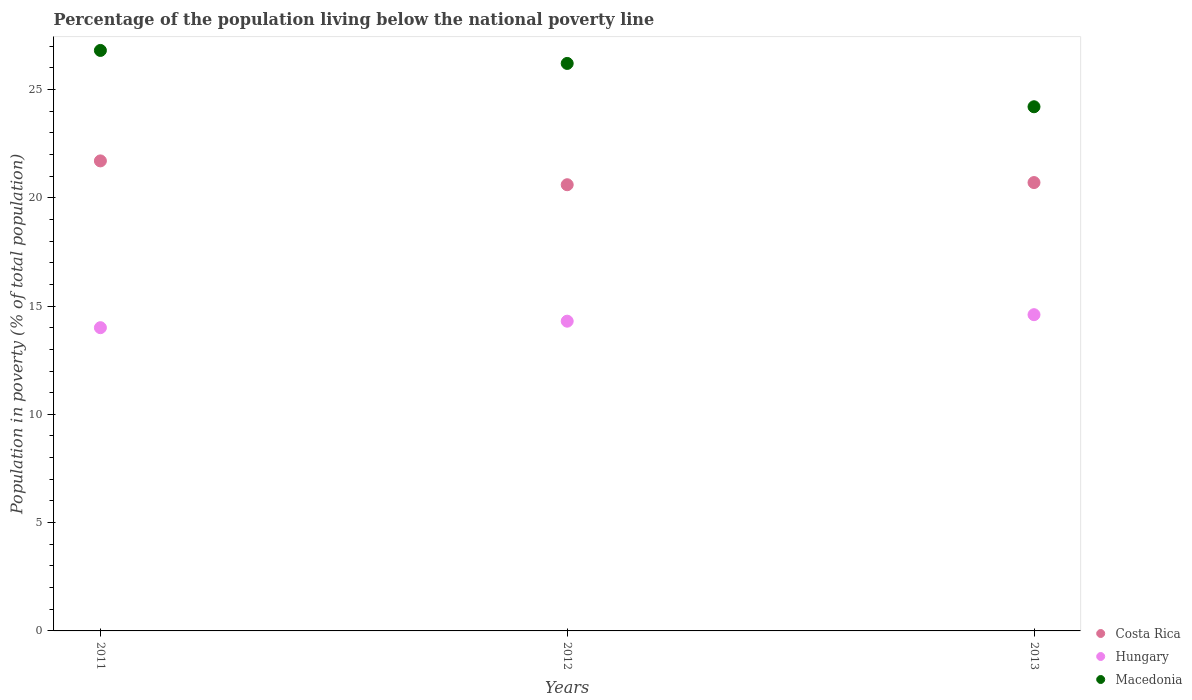How many different coloured dotlines are there?
Provide a succinct answer. 3. Is the number of dotlines equal to the number of legend labels?
Ensure brevity in your answer.  Yes. What is the percentage of the population living below the national poverty line in Costa Rica in 2013?
Your answer should be very brief. 20.7. Across all years, what is the maximum percentage of the population living below the national poverty line in Macedonia?
Your answer should be very brief. 26.8. Across all years, what is the minimum percentage of the population living below the national poverty line in Macedonia?
Make the answer very short. 24.2. In which year was the percentage of the population living below the national poverty line in Costa Rica maximum?
Provide a short and direct response. 2011. What is the total percentage of the population living below the national poverty line in Macedonia in the graph?
Your response must be concise. 77.2. What is the difference between the percentage of the population living below the national poverty line in Hungary in 2012 and that in 2013?
Your response must be concise. -0.3. What is the difference between the percentage of the population living below the national poverty line in Hungary in 2011 and the percentage of the population living below the national poverty line in Macedonia in 2013?
Ensure brevity in your answer.  -10.2. What is the average percentage of the population living below the national poverty line in Hungary per year?
Provide a succinct answer. 14.3. In the year 2011, what is the difference between the percentage of the population living below the national poverty line in Macedonia and percentage of the population living below the national poverty line in Costa Rica?
Offer a very short reply. 5.1. In how many years, is the percentage of the population living below the national poverty line in Costa Rica greater than 1 %?
Make the answer very short. 3. What is the ratio of the percentage of the population living below the national poverty line in Costa Rica in 2011 to that in 2013?
Offer a terse response. 1.05. Is the difference between the percentage of the population living below the national poverty line in Macedonia in 2011 and 2012 greater than the difference between the percentage of the population living below the national poverty line in Costa Rica in 2011 and 2012?
Offer a very short reply. No. What is the difference between the highest and the second highest percentage of the population living below the national poverty line in Macedonia?
Ensure brevity in your answer.  0.6. What is the difference between the highest and the lowest percentage of the population living below the national poverty line in Macedonia?
Keep it short and to the point. 2.6. In how many years, is the percentage of the population living below the national poverty line in Costa Rica greater than the average percentage of the population living below the national poverty line in Costa Rica taken over all years?
Offer a very short reply. 1. Is the sum of the percentage of the population living below the national poverty line in Macedonia in 2011 and 2013 greater than the maximum percentage of the population living below the national poverty line in Costa Rica across all years?
Provide a succinct answer. Yes. Is it the case that in every year, the sum of the percentage of the population living below the national poverty line in Costa Rica and percentage of the population living below the national poverty line in Macedonia  is greater than the percentage of the population living below the national poverty line in Hungary?
Your answer should be compact. Yes. Does the percentage of the population living below the national poverty line in Macedonia monotonically increase over the years?
Offer a terse response. No. Is the percentage of the population living below the national poverty line in Macedonia strictly less than the percentage of the population living below the national poverty line in Hungary over the years?
Keep it short and to the point. No. How many dotlines are there?
Keep it short and to the point. 3. How many years are there in the graph?
Keep it short and to the point. 3. What is the difference between two consecutive major ticks on the Y-axis?
Offer a very short reply. 5. Are the values on the major ticks of Y-axis written in scientific E-notation?
Offer a very short reply. No. Does the graph contain any zero values?
Your answer should be compact. No. Does the graph contain grids?
Your answer should be very brief. No. What is the title of the graph?
Keep it short and to the point. Percentage of the population living below the national poverty line. What is the label or title of the X-axis?
Your response must be concise. Years. What is the label or title of the Y-axis?
Give a very brief answer. Population in poverty (% of total population). What is the Population in poverty (% of total population) of Costa Rica in 2011?
Give a very brief answer. 21.7. What is the Population in poverty (% of total population) in Hungary in 2011?
Offer a very short reply. 14. What is the Population in poverty (% of total population) in Macedonia in 2011?
Offer a terse response. 26.8. What is the Population in poverty (% of total population) in Costa Rica in 2012?
Keep it short and to the point. 20.6. What is the Population in poverty (% of total population) of Macedonia in 2012?
Offer a terse response. 26.2. What is the Population in poverty (% of total population) in Costa Rica in 2013?
Give a very brief answer. 20.7. What is the Population in poverty (% of total population) of Hungary in 2013?
Your response must be concise. 14.6. What is the Population in poverty (% of total population) in Macedonia in 2013?
Your response must be concise. 24.2. Across all years, what is the maximum Population in poverty (% of total population) in Costa Rica?
Provide a succinct answer. 21.7. Across all years, what is the maximum Population in poverty (% of total population) in Macedonia?
Ensure brevity in your answer.  26.8. Across all years, what is the minimum Population in poverty (% of total population) of Costa Rica?
Offer a very short reply. 20.6. Across all years, what is the minimum Population in poverty (% of total population) in Hungary?
Your response must be concise. 14. Across all years, what is the minimum Population in poverty (% of total population) of Macedonia?
Ensure brevity in your answer.  24.2. What is the total Population in poverty (% of total population) of Costa Rica in the graph?
Your answer should be compact. 63. What is the total Population in poverty (% of total population) in Hungary in the graph?
Your answer should be very brief. 42.9. What is the total Population in poverty (% of total population) in Macedonia in the graph?
Your response must be concise. 77.2. What is the difference between the Population in poverty (% of total population) of Costa Rica in 2011 and that in 2012?
Provide a succinct answer. 1.1. What is the difference between the Population in poverty (% of total population) of Hungary in 2011 and that in 2013?
Offer a very short reply. -0.6. What is the difference between the Population in poverty (% of total population) in Macedonia in 2012 and that in 2013?
Your answer should be compact. 2. What is the difference between the Population in poverty (% of total population) in Costa Rica in 2011 and the Population in poverty (% of total population) in Hungary in 2012?
Make the answer very short. 7.4. What is the difference between the Population in poverty (% of total population) in Hungary in 2011 and the Population in poverty (% of total population) in Macedonia in 2012?
Give a very brief answer. -12.2. What is the difference between the Population in poverty (% of total population) of Costa Rica in 2011 and the Population in poverty (% of total population) of Macedonia in 2013?
Provide a succinct answer. -2.5. What is the average Population in poverty (% of total population) of Costa Rica per year?
Make the answer very short. 21. What is the average Population in poverty (% of total population) of Hungary per year?
Provide a short and direct response. 14.3. What is the average Population in poverty (% of total population) of Macedonia per year?
Provide a short and direct response. 25.73. In the year 2011, what is the difference between the Population in poverty (% of total population) of Costa Rica and Population in poverty (% of total population) of Macedonia?
Make the answer very short. -5.1. In the year 2011, what is the difference between the Population in poverty (% of total population) of Hungary and Population in poverty (% of total population) of Macedonia?
Offer a very short reply. -12.8. In the year 2012, what is the difference between the Population in poverty (% of total population) of Costa Rica and Population in poverty (% of total population) of Hungary?
Provide a short and direct response. 6.3. In the year 2012, what is the difference between the Population in poverty (% of total population) of Costa Rica and Population in poverty (% of total population) of Macedonia?
Give a very brief answer. -5.6. In the year 2012, what is the difference between the Population in poverty (% of total population) of Hungary and Population in poverty (% of total population) of Macedonia?
Ensure brevity in your answer.  -11.9. In the year 2013, what is the difference between the Population in poverty (% of total population) in Costa Rica and Population in poverty (% of total population) in Hungary?
Give a very brief answer. 6.1. In the year 2013, what is the difference between the Population in poverty (% of total population) of Costa Rica and Population in poverty (% of total population) of Macedonia?
Give a very brief answer. -3.5. What is the ratio of the Population in poverty (% of total population) in Costa Rica in 2011 to that in 2012?
Make the answer very short. 1.05. What is the ratio of the Population in poverty (% of total population) of Hungary in 2011 to that in 2012?
Your answer should be very brief. 0.98. What is the ratio of the Population in poverty (% of total population) of Macedonia in 2011 to that in 2012?
Make the answer very short. 1.02. What is the ratio of the Population in poverty (% of total population) in Costa Rica in 2011 to that in 2013?
Your response must be concise. 1.05. What is the ratio of the Population in poverty (% of total population) of Hungary in 2011 to that in 2013?
Your answer should be very brief. 0.96. What is the ratio of the Population in poverty (% of total population) in Macedonia in 2011 to that in 2013?
Keep it short and to the point. 1.11. What is the ratio of the Population in poverty (% of total population) of Costa Rica in 2012 to that in 2013?
Your answer should be compact. 1. What is the ratio of the Population in poverty (% of total population) in Hungary in 2012 to that in 2013?
Your answer should be very brief. 0.98. What is the ratio of the Population in poverty (% of total population) in Macedonia in 2012 to that in 2013?
Provide a short and direct response. 1.08. What is the difference between the highest and the lowest Population in poverty (% of total population) of Costa Rica?
Your answer should be very brief. 1.1. 